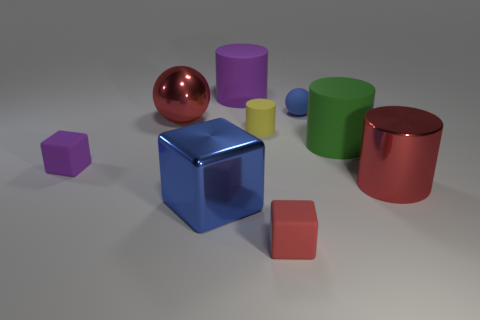Are there the same number of large purple cylinders that are to the right of the blue matte object and green cylinders?
Offer a very short reply. No. The purple matte thing that is the same shape as the big blue object is what size?
Provide a succinct answer. Small. Does the big blue thing have the same shape as the red metal object to the right of the large red shiny ball?
Your response must be concise. No. There is a purple thing that is behind the purple cube that is behind the large blue object; how big is it?
Provide a succinct answer. Large. Are there an equal number of purple objects in front of the green matte thing and blue rubber things that are in front of the big ball?
Keep it short and to the point. No. There is a large metallic thing that is the same shape as the small yellow thing; what color is it?
Ensure brevity in your answer.  Red. What number of small rubber blocks are the same color as the large ball?
Keep it short and to the point. 1. There is a red metal thing that is behind the green thing; does it have the same shape as the big green thing?
Your answer should be very brief. No. The purple matte thing in front of the blue object that is behind the purple rubber object in front of the big purple cylinder is what shape?
Your answer should be compact. Cube. How big is the matte ball?
Your answer should be very brief. Small. 